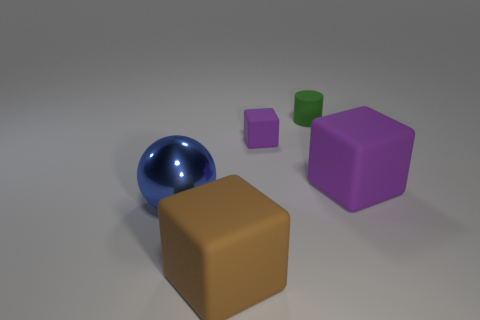Is the blue object the same size as the cylinder?
Your response must be concise. No. Are there any other things that have the same shape as the big brown matte object?
Your answer should be compact. Yes. Is the material of the tiny green thing the same as the block that is to the left of the small rubber cube?
Offer a terse response. Yes. Do the large rubber block that is in front of the large sphere and the big metal thing have the same color?
Offer a very short reply. No. How many large things are both to the right of the big shiny ball and left of the cylinder?
Offer a very short reply. 1. How many other objects are there of the same material as the small purple thing?
Provide a short and direct response. 3. Is the material of the small green thing that is behind the large brown thing the same as the sphere?
Ensure brevity in your answer.  No. How big is the purple block to the left of the large cube behind the big block to the left of the green rubber object?
Offer a terse response. Small. What number of other things are there of the same color as the metallic ball?
Give a very brief answer. 0. What is the shape of the purple object that is the same size as the metal sphere?
Your answer should be compact. Cube. 